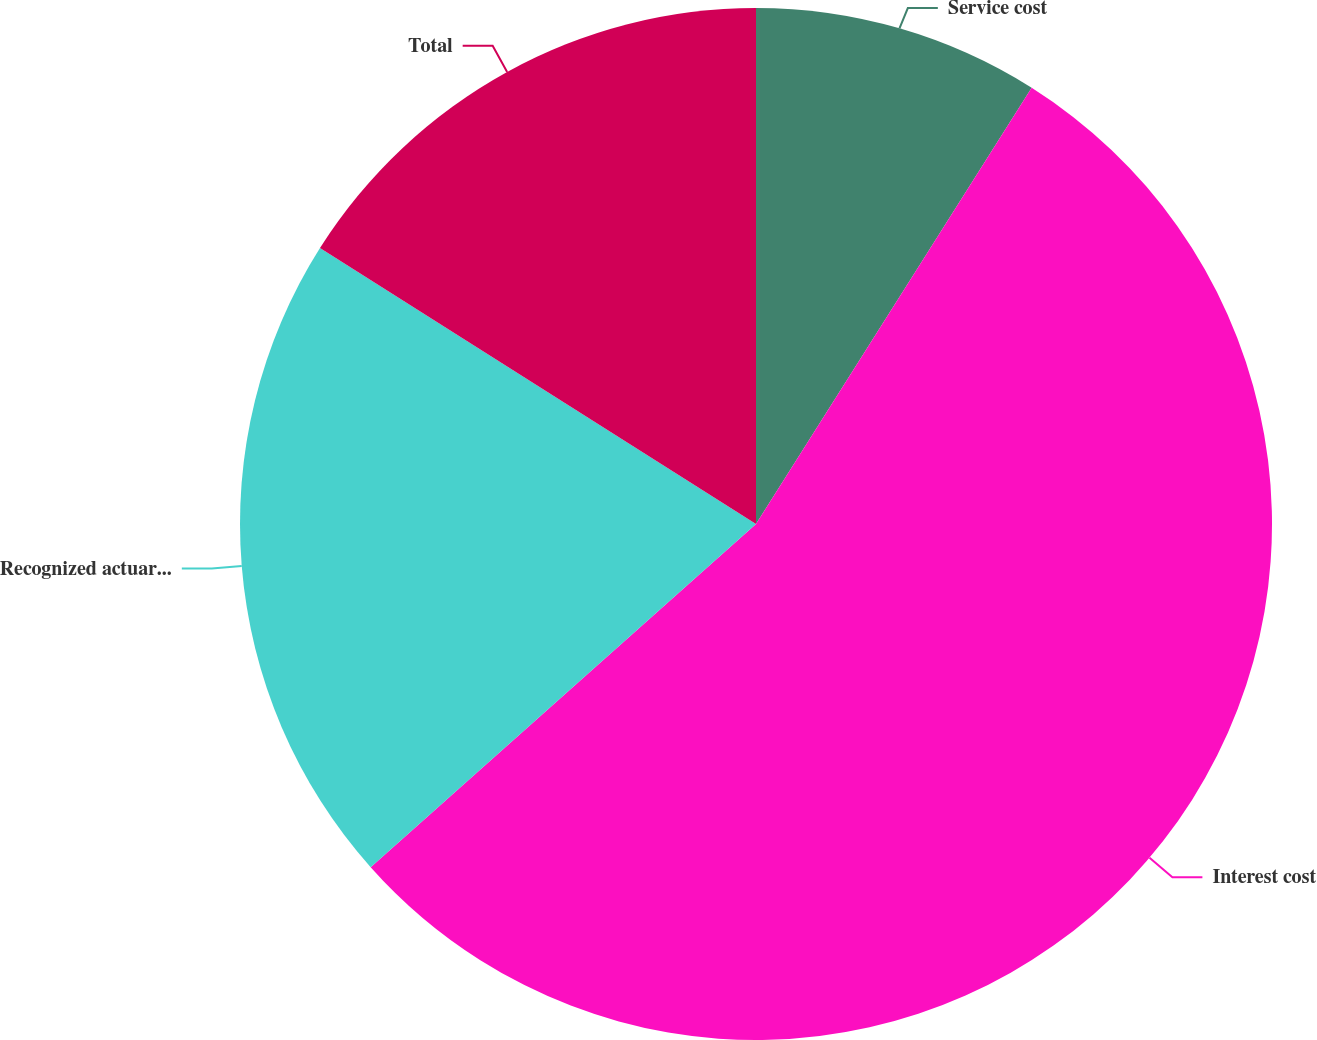Convert chart to OTSL. <chart><loc_0><loc_0><loc_500><loc_500><pie_chart><fcel>Service cost<fcel>Interest cost<fcel>Recognized actuarial (gain)<fcel>Total<nl><fcel>8.97%<fcel>54.45%<fcel>20.56%<fcel>16.02%<nl></chart> 